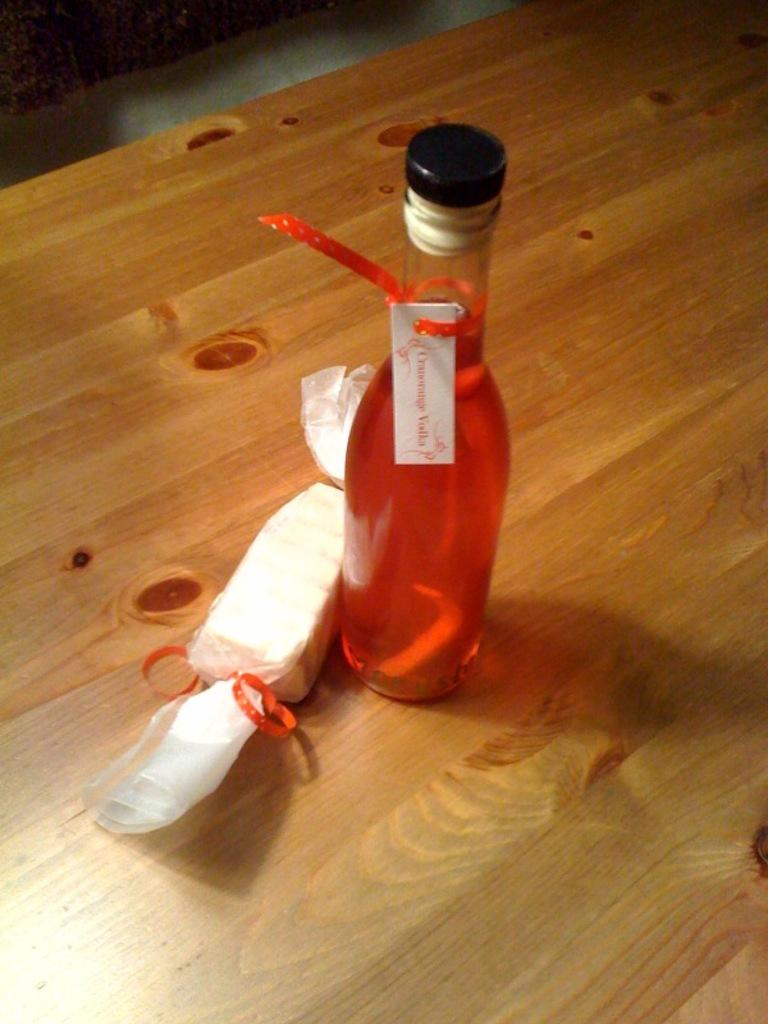What is in the bottle that is visible in the image? There is a bottle with liquid in the image. Where is the bottle located in the image? The bottle is on a wooden table. What else can be seen near the bottle in the image? There is a chocolate with a wrapper on the left side of the bottle. How many eyes does the grandmother have in the image? There is no grandmother present in the image, so it is not possible to determine the number of eyes she might have. 